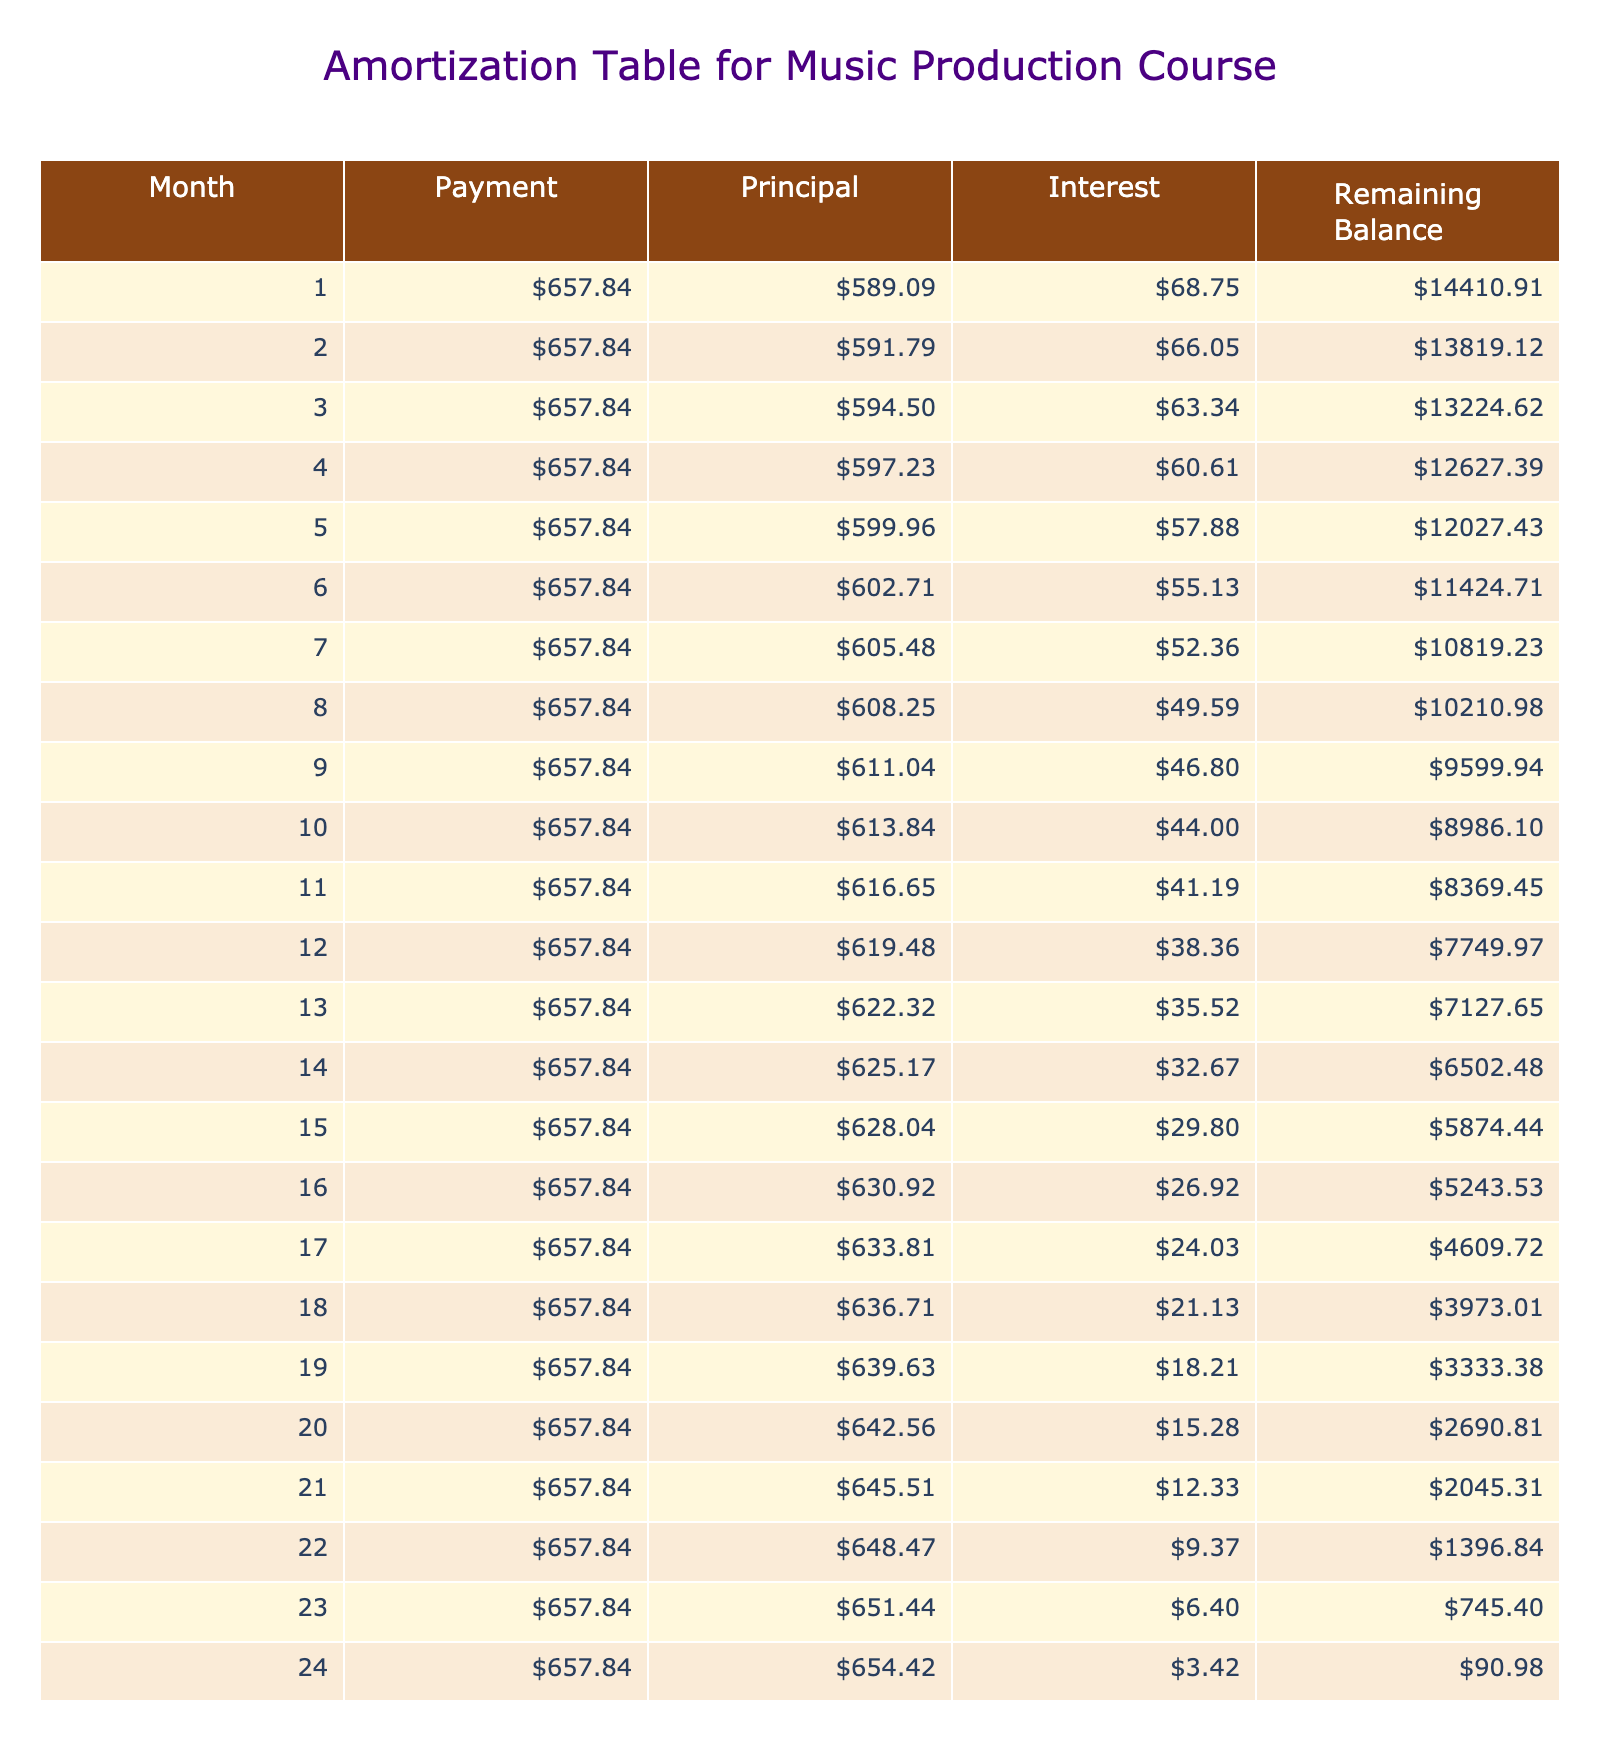What is the total amount paid over the life of the loan? The total payment is listed as $15788.08 in the table, which represents the complete amount that will be paid over the loan term.
Answer: $15788.08 What is the monthly payment amount for the loan? The monthly payment is stated in the table as $657.84, which details what is required to be paid each month for the duration of the loan.
Answer: $657.84 How much interest will be paid in total over the term of the loan? The total interest is shown as $788.08, which is the total amount that will be paid in interest on the loan by the end of the term.
Answer: $788.08 Is the monthly payment greater than $600? The monthly payment is $657.84, which is indeed greater than $600, confirming that the statement is true.
Answer: Yes What is the principal amount paid in the last month? In the last month (month 24), the principal payment can be calculated by analyzing the remaining balance and the interest paid for the last month. Assuming a diminishing balance, we can see the difference between the payment and interest is quite stable throughout, approximating the final principal payment at $657.84 minus the interest calculated for the last month.
Answer: Approximately $657.84 (with a very small adjustment based on interest) How much will the remaining balance be after the 12th month? To find the remaining balance after the 12th month, we need to sum all monthly payments and interest paid for the first 12 months, then deduct from the original loan amount. By the 12th payment, the balance should be under $7,500 after accounting for all deductions.
Answer: Approximately around $7,500 What is the total payment made in the last month? Since the monthly payment does not change, it will remain the same throughout, so the total payment made in the last month will also amount to $657.84.
Answer: $657.84 If the interest rate were to increase to 6%, would the monthly payment be higher or lower? An increase in the interest rate would increase the amount of interest calculated in each monthly payment. Therefore, the monthly payment would need to be higher to accommodate for the additional interest costs.
Answer: Higher What was the purpose of this loan? It is specified that the purpose of the loan is for a Music Production Course, ensuring we understand the context of this financial decision.
Answer: Music Production Course 